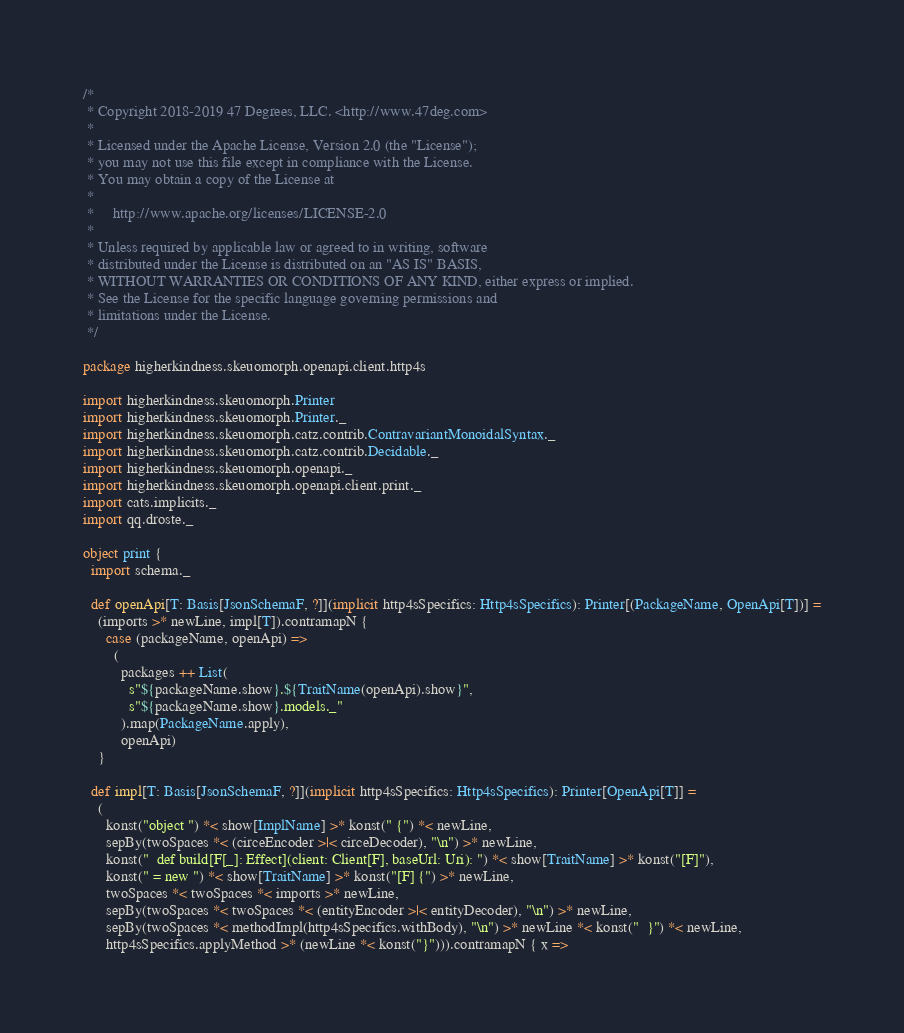Convert code to text. <code><loc_0><loc_0><loc_500><loc_500><_Scala_>/*
 * Copyright 2018-2019 47 Degrees, LLC. <http://www.47deg.com>
 *
 * Licensed under the Apache License, Version 2.0 (the "License");
 * you may not use this file except in compliance with the License.
 * You may obtain a copy of the License at
 *
 *     http://www.apache.org/licenses/LICENSE-2.0
 *
 * Unless required by applicable law or agreed to in writing, software
 * distributed under the License is distributed on an "AS IS" BASIS,
 * WITHOUT WARRANTIES OR CONDITIONS OF ANY KIND, either express or implied.
 * See the License for the specific language governing permissions and
 * limitations under the License.
 */

package higherkindness.skeuomorph.openapi.client.http4s

import higherkindness.skeuomorph.Printer
import higherkindness.skeuomorph.Printer._
import higherkindness.skeuomorph.catz.contrib.ContravariantMonoidalSyntax._
import higherkindness.skeuomorph.catz.contrib.Decidable._
import higherkindness.skeuomorph.openapi._
import higherkindness.skeuomorph.openapi.client.print._
import cats.implicits._
import qq.droste._

object print {
  import schema._

  def openApi[T: Basis[JsonSchemaF, ?]](implicit http4sSpecifics: Http4sSpecifics): Printer[(PackageName, OpenApi[T])] =
    (imports >* newLine, impl[T]).contramapN {
      case (packageName, openApi) =>
        (
          packages ++ List(
            s"${packageName.show}.${TraitName(openApi).show}",
            s"${packageName.show}.models._"
          ).map(PackageName.apply),
          openApi)
    }

  def impl[T: Basis[JsonSchemaF, ?]](implicit http4sSpecifics: Http4sSpecifics): Printer[OpenApi[T]] =
    (
      konst("object ") *< show[ImplName] >* konst(" {") *< newLine,
      sepBy(twoSpaces *< (circeEncoder >|< circeDecoder), "\n") >* newLine,
      konst("  def build[F[_]: Effect](client: Client[F], baseUrl: Uri): ") *< show[TraitName] >* konst("[F]"),
      konst(" = new ") *< show[TraitName] >* konst("[F] {") >* newLine,
      twoSpaces *< twoSpaces *< imports >* newLine,
      sepBy(twoSpaces *< twoSpaces *< (entityEncoder >|< entityDecoder), "\n") >* newLine,
      sepBy(twoSpaces *< methodImpl(http4sSpecifics.withBody), "\n") >* newLine *< konst("  }") *< newLine,
      http4sSpecifics.applyMethod >* (newLine *< konst("}"))).contramapN { x =></code> 